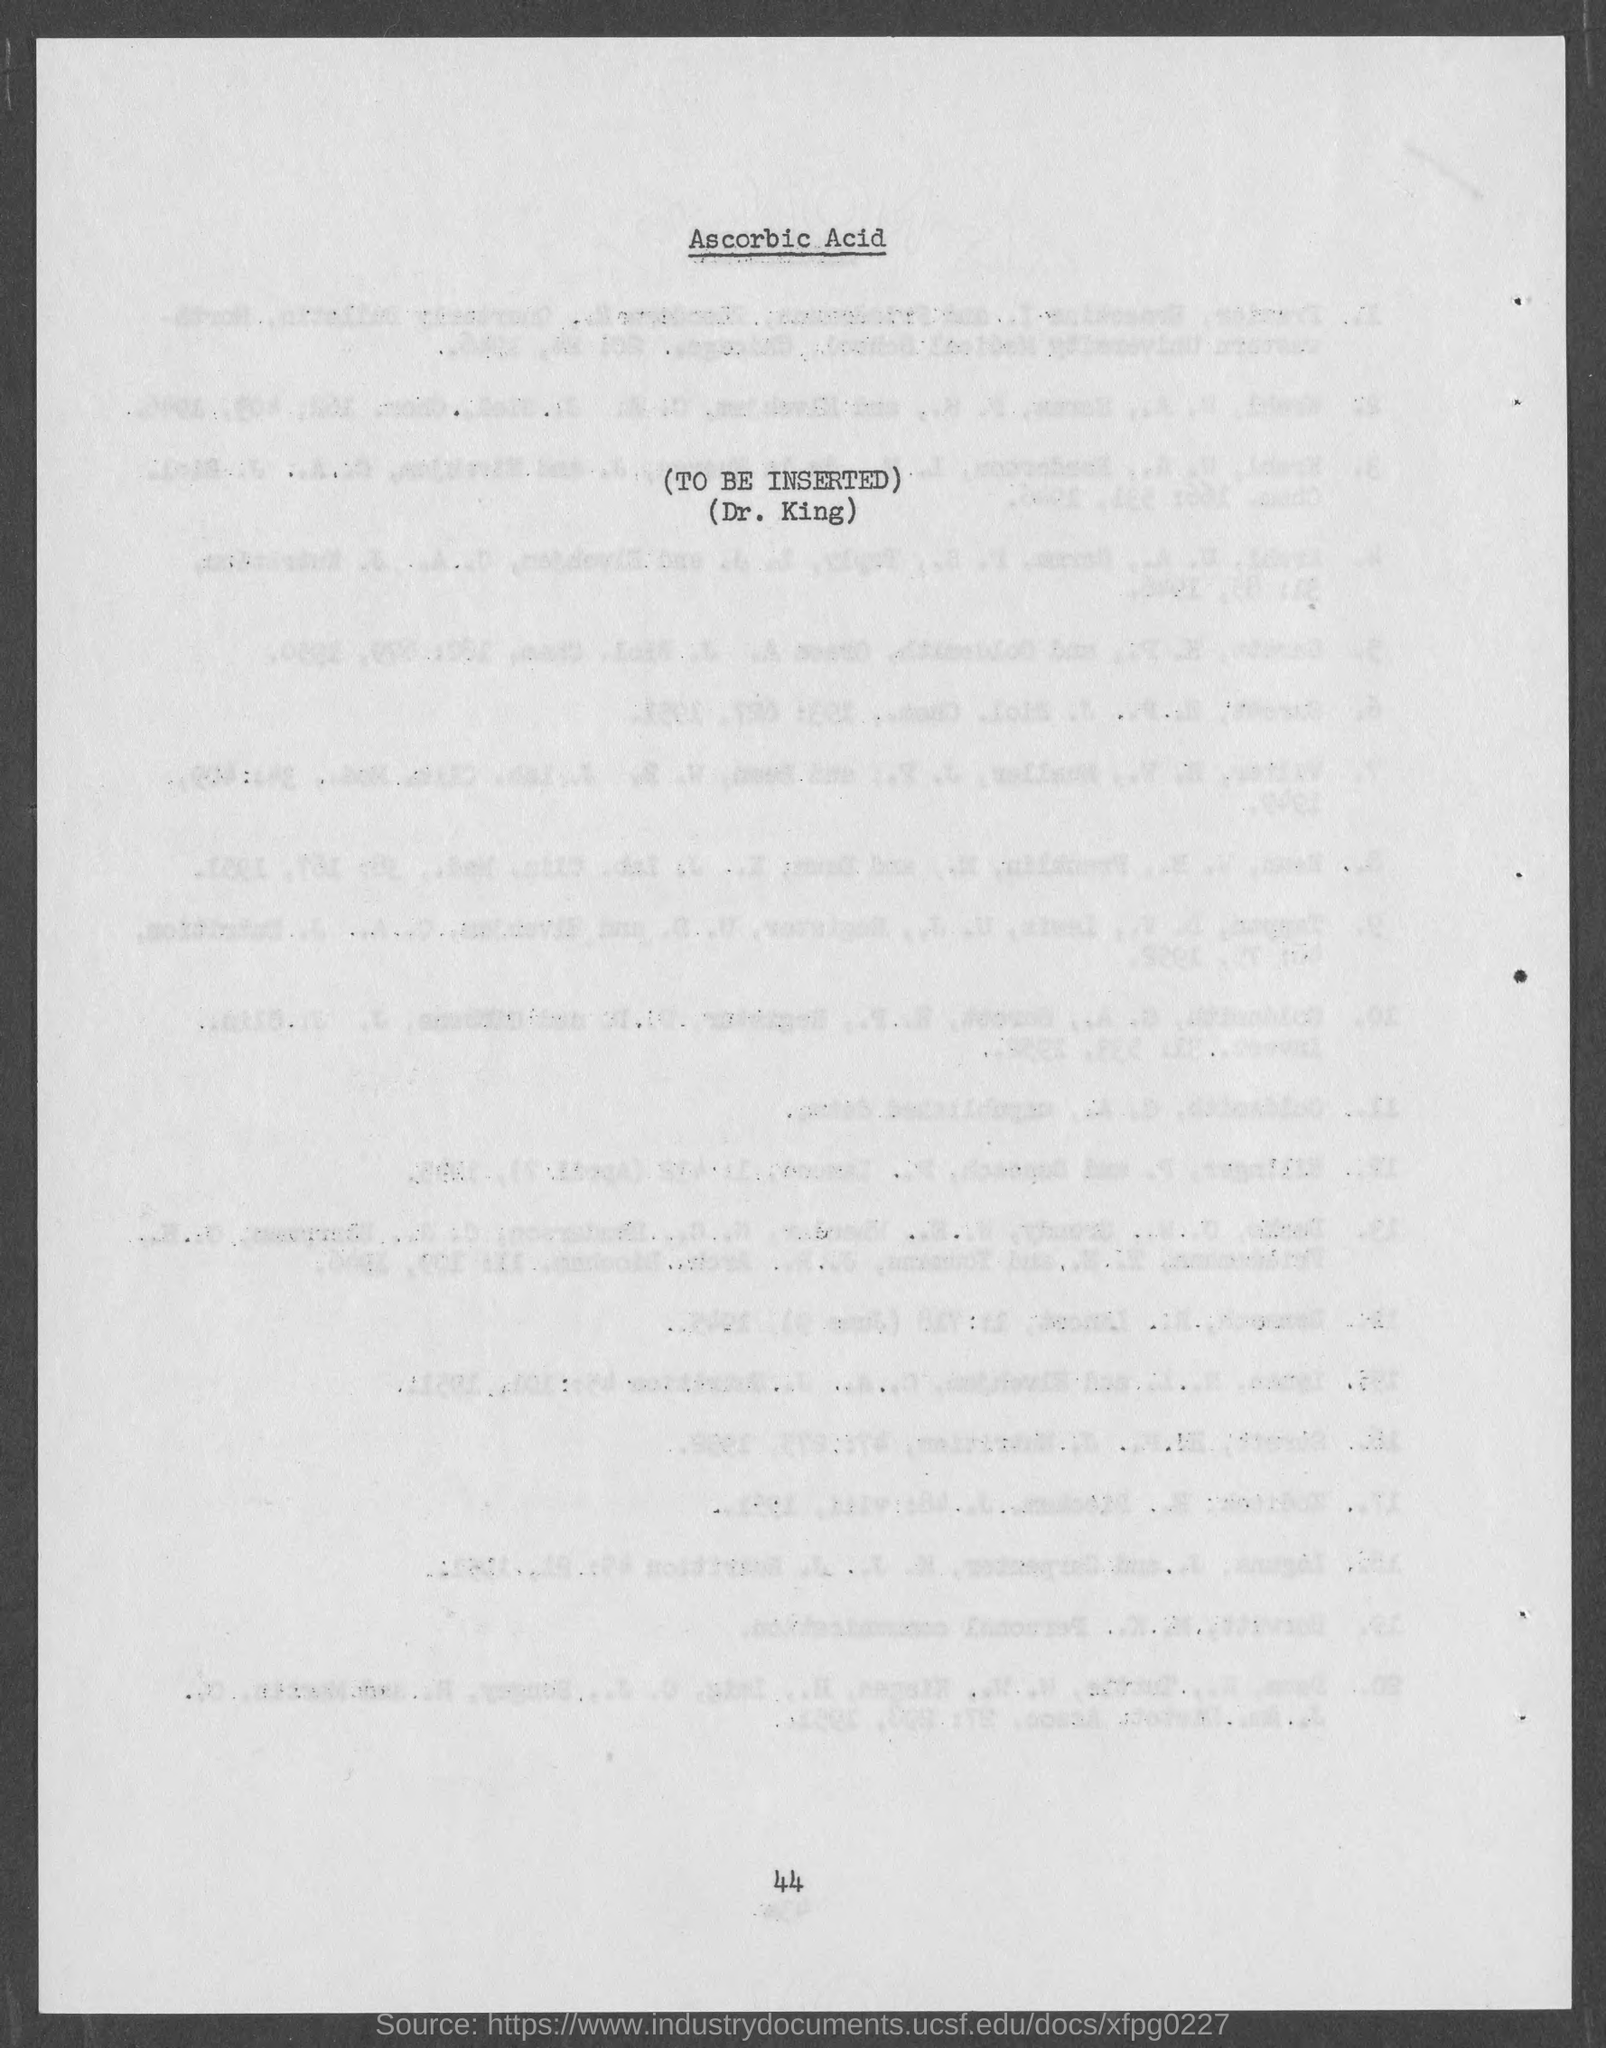What is the page number at bottom of the page?
Provide a short and direct response. 44. 